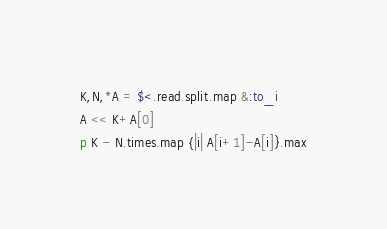<code> <loc_0><loc_0><loc_500><loc_500><_Ruby_>K,N,*A = $<.read.split.map &:to_i
A << K+A[0]
p K - N.times.map {|i| A[i+1]-A[i]}.max</code> 